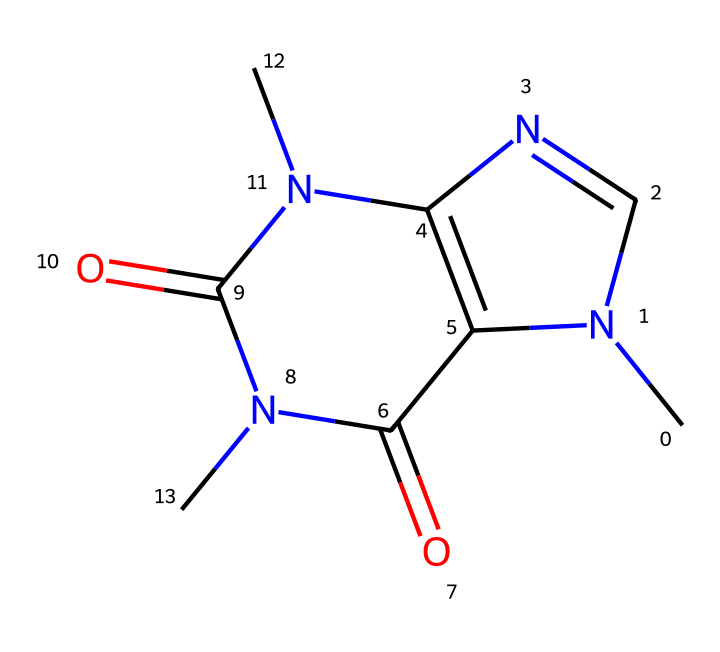What is the name of this chemical? This chemical's structure corresponds to caffeine, which is a well-known stimulant found in coffee. The connections and arrangement of atoms follow the known structure of caffeine.
Answer: caffeine How many nitrogen atoms are present in the chemical structure? By analyzing the SMILES representation, we observe three nitrogen (N) atoms present, as indicated by the occurrences of 'N' in the structure.
Answer: three What is the total number of carbon atoms in this structure? The SMILES reveals a total of eight carbon (C) atoms present, as counted from all occurrences of 'C' in the structure.
Answer: eight Which part of the structure indicates it’s a Cage compound? The fused ring system seen in the structure is characteristic of Cage compounds, referring to the cyclic arrangement of atoms that create a closed structure or "cage."
Answer: fused ring What functional groups are observed in the structure? The structure contains amide-functional groups (C(=O)N) along with carbonyl groups (C=O), indicated by the associated arrangements.
Answer: amide and carbonyl How is the structure related to its stimulant properties? The presence of nitrogen and the specific arrangement of atoms in caffeine are crucial for its stimulant effects, as these groups enhance interaction with neurotransmitter receptors.
Answer: nitrogen What type of isomerism is exhibited in caffeine's structure? Caffeine exhibits structural isomerism, where different structural forms (isomers) can arise due to variations in the arrangement of atoms, which affects its properties.
Answer: structural isomerism 